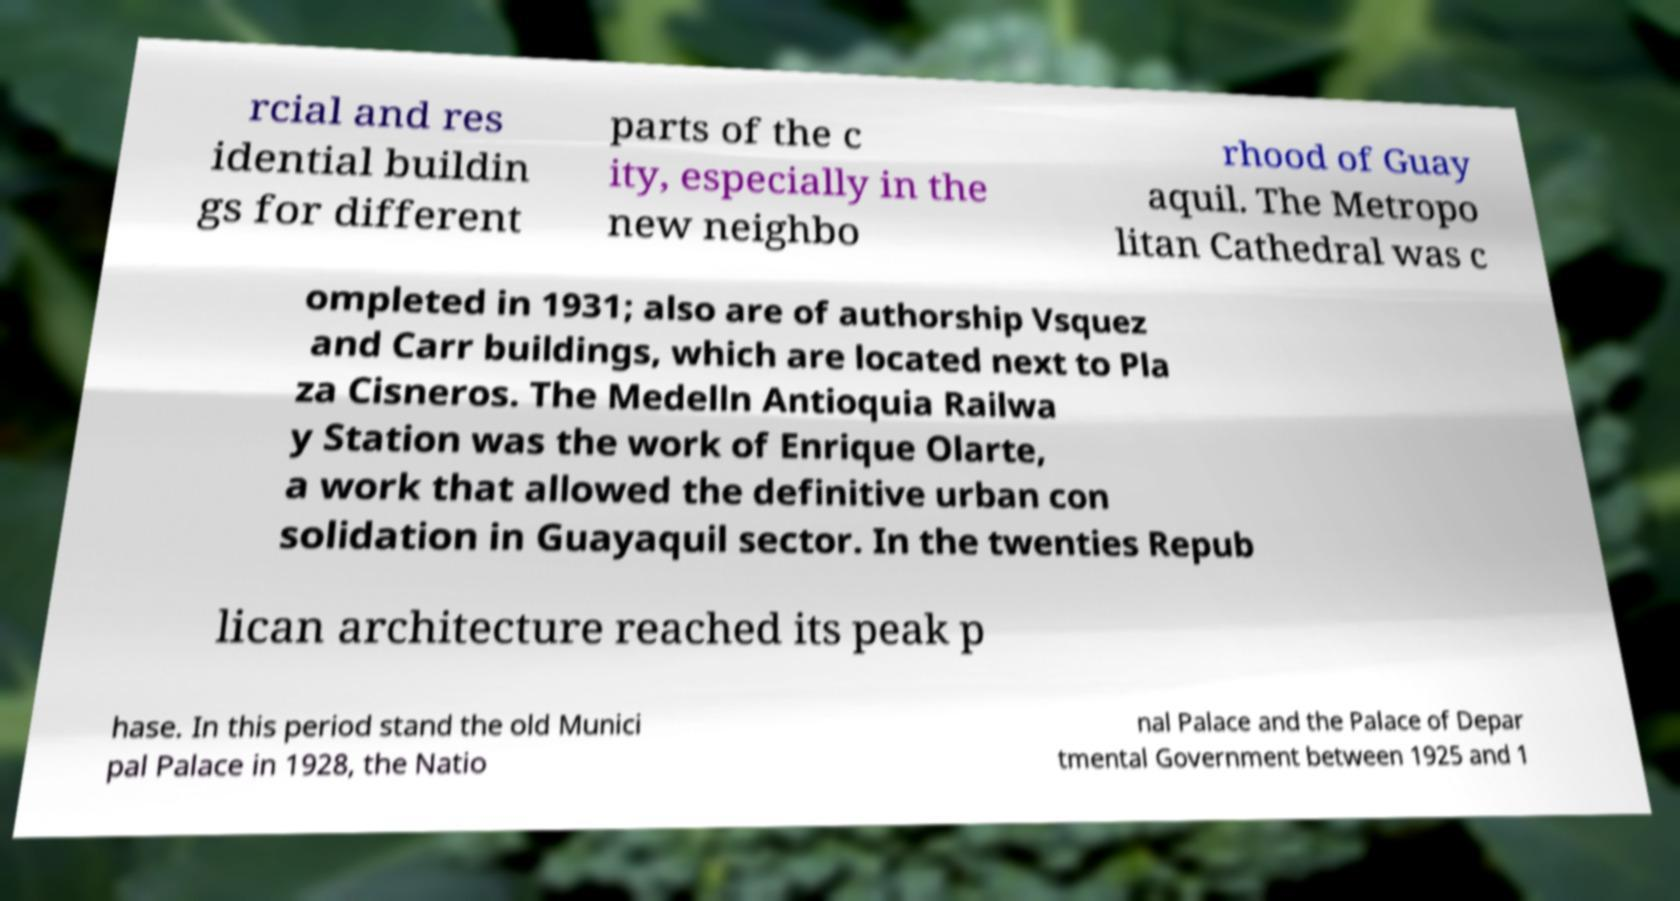There's text embedded in this image that I need extracted. Can you transcribe it verbatim? rcial and res idential buildin gs for different parts of the c ity, especially in the new neighbo rhood of Guay aquil. The Metropo litan Cathedral was c ompleted in 1931; also are of authorship Vsquez and Carr buildings, which are located next to Pla za Cisneros. The Medelln Antioquia Railwa y Station was the work of Enrique Olarte, a work that allowed the definitive urban con solidation in Guayaquil sector. In the twenties Repub lican architecture reached its peak p hase. In this period stand the old Munici pal Palace in 1928, the Natio nal Palace and the Palace of Depar tmental Government between 1925 and 1 